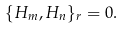Convert formula to latex. <formula><loc_0><loc_0><loc_500><loc_500>\{ H _ { m } , H _ { n } \} _ { r } = 0 .</formula> 